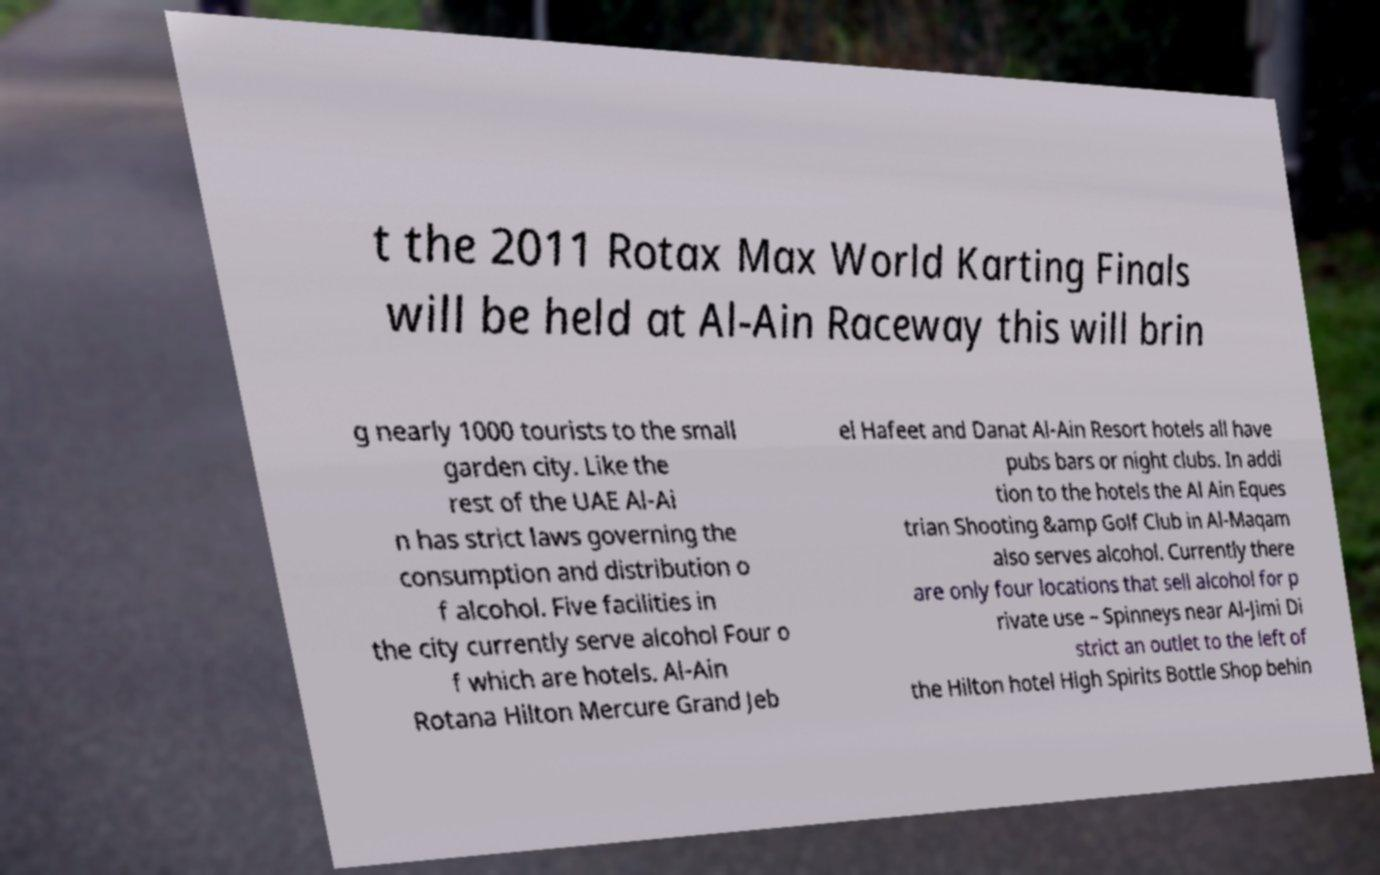For documentation purposes, I need the text within this image transcribed. Could you provide that? t the 2011 Rotax Max World Karting Finals will be held at Al-Ain Raceway this will brin g nearly 1000 tourists to the small garden city. Like the rest of the UAE Al-Ai n has strict laws governing the consumption and distribution o f alcohol. Five facilities in the city currently serve alcohol Four o f which are hotels. Al-Ain Rotana Hilton Mercure Grand Jeb el Hafeet and Danat Al-Ain Resort hotels all have pubs bars or night clubs. In addi tion to the hotels the Al Ain Eques trian Shooting &amp Golf Club in Al-Maqam also serves alcohol. Currently there are only four locations that sell alcohol for p rivate use – Spinneys near Al-Jimi Di strict an outlet to the left of the Hilton hotel High Spirits Bottle Shop behin 